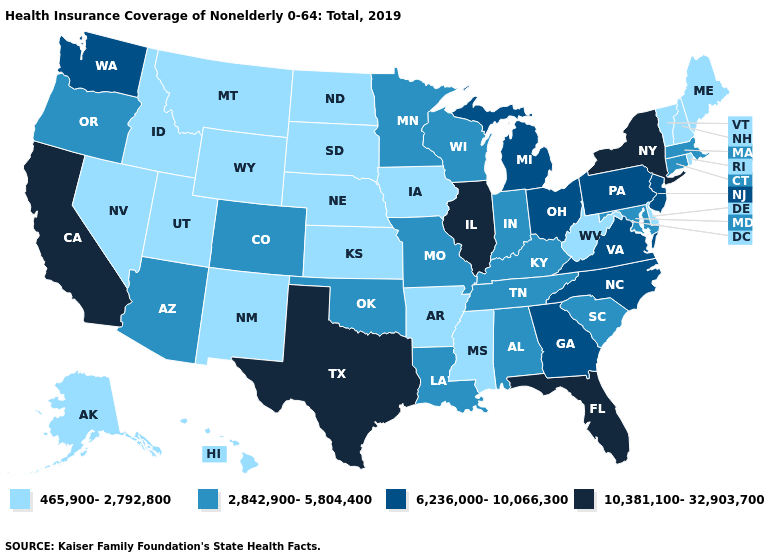Which states have the lowest value in the South?
Be succinct. Arkansas, Delaware, Mississippi, West Virginia. What is the highest value in the West ?
Be succinct. 10,381,100-32,903,700. Name the states that have a value in the range 2,842,900-5,804,400?
Quick response, please. Alabama, Arizona, Colorado, Connecticut, Indiana, Kentucky, Louisiana, Maryland, Massachusetts, Minnesota, Missouri, Oklahoma, Oregon, South Carolina, Tennessee, Wisconsin. Does the map have missing data?
Concise answer only. No. How many symbols are there in the legend?
Concise answer only. 4. Which states have the lowest value in the Northeast?
Keep it brief. Maine, New Hampshire, Rhode Island, Vermont. Which states have the lowest value in the USA?
Quick response, please. Alaska, Arkansas, Delaware, Hawaii, Idaho, Iowa, Kansas, Maine, Mississippi, Montana, Nebraska, Nevada, New Hampshire, New Mexico, North Dakota, Rhode Island, South Dakota, Utah, Vermont, West Virginia, Wyoming. What is the highest value in states that border Tennessee?
Concise answer only. 6,236,000-10,066,300. Does the first symbol in the legend represent the smallest category?
Concise answer only. Yes. Name the states that have a value in the range 6,236,000-10,066,300?
Concise answer only. Georgia, Michigan, New Jersey, North Carolina, Ohio, Pennsylvania, Virginia, Washington. Does Texas have the highest value in the South?
Be succinct. Yes. Among the states that border New Mexico , does Texas have the highest value?
Keep it brief. Yes. How many symbols are there in the legend?
Concise answer only. 4. What is the value of Kansas?
Short answer required. 465,900-2,792,800. What is the value of West Virginia?
Answer briefly. 465,900-2,792,800. 